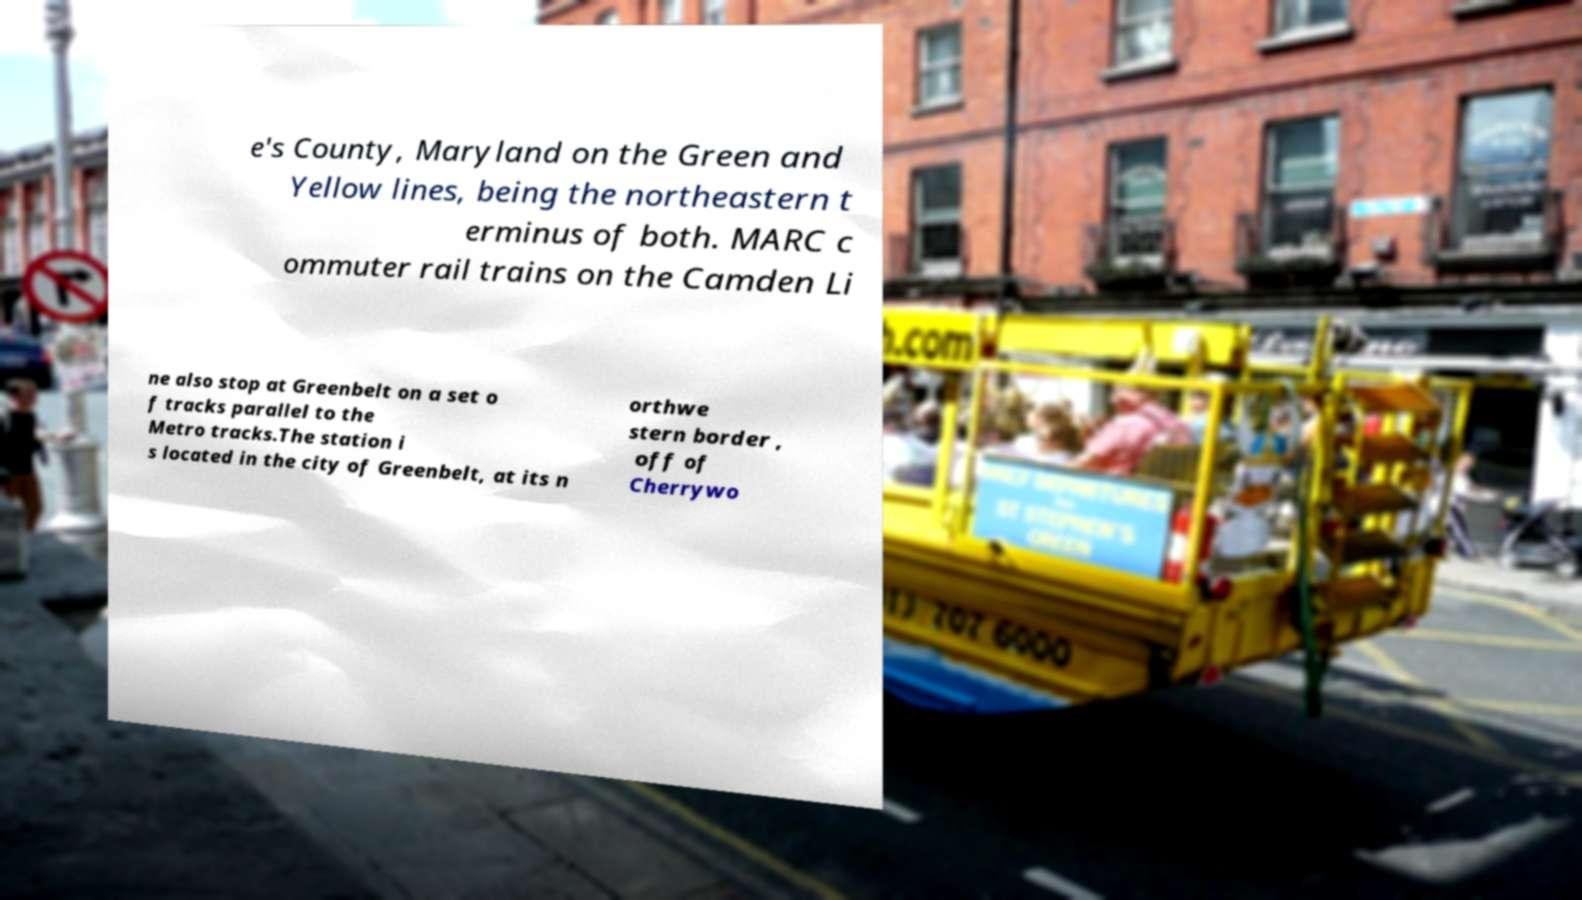Could you assist in decoding the text presented in this image and type it out clearly? e's County, Maryland on the Green and Yellow lines, being the northeastern t erminus of both. MARC c ommuter rail trains on the Camden Li ne also stop at Greenbelt on a set o f tracks parallel to the Metro tracks.The station i s located in the city of Greenbelt, at its n orthwe stern border , off of Cherrywo 